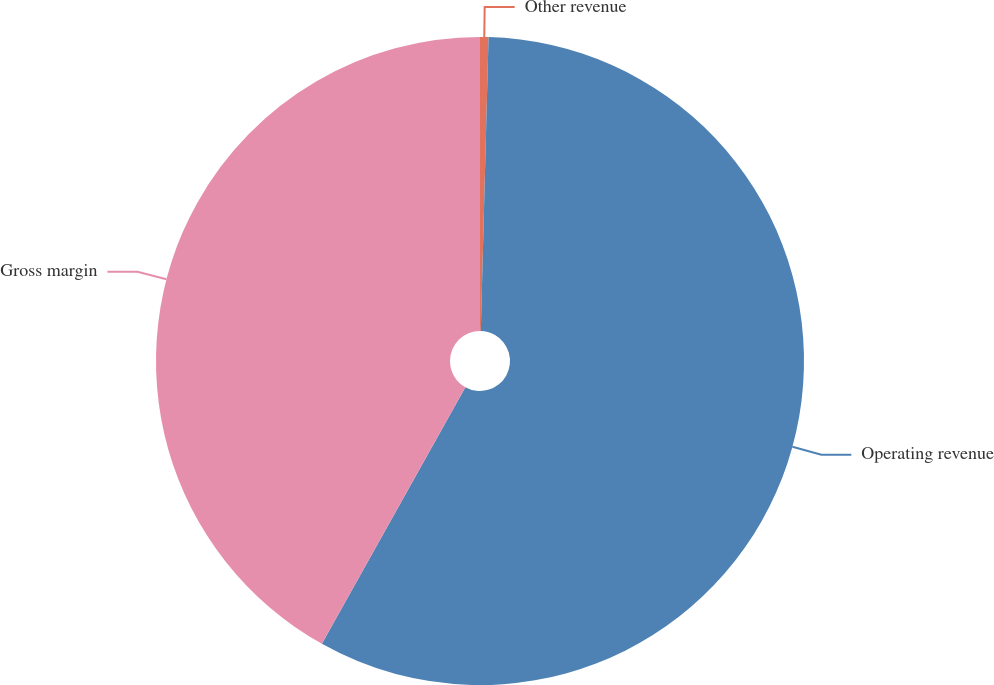Convert chart. <chart><loc_0><loc_0><loc_500><loc_500><pie_chart><fcel>Other revenue<fcel>Operating revenue<fcel>Gross margin<nl><fcel>0.42%<fcel>57.7%<fcel>41.89%<nl></chart> 